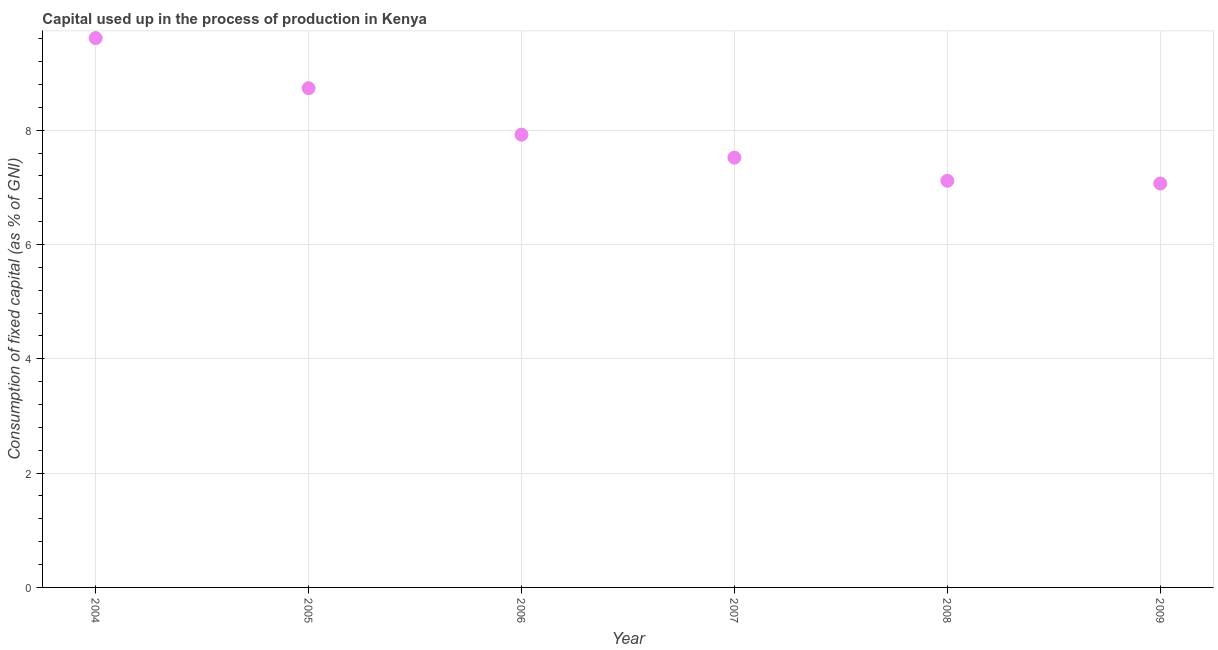What is the consumption of fixed capital in 2008?
Your response must be concise. 7.12. Across all years, what is the maximum consumption of fixed capital?
Keep it short and to the point. 9.61. Across all years, what is the minimum consumption of fixed capital?
Keep it short and to the point. 7.07. What is the sum of the consumption of fixed capital?
Provide a short and direct response. 47.97. What is the difference between the consumption of fixed capital in 2007 and 2008?
Offer a terse response. 0.4. What is the average consumption of fixed capital per year?
Provide a short and direct response. 8. What is the median consumption of fixed capital?
Your answer should be compact. 7.72. What is the ratio of the consumption of fixed capital in 2007 to that in 2008?
Provide a short and direct response. 1.06. Is the consumption of fixed capital in 2004 less than that in 2009?
Ensure brevity in your answer.  No. Is the difference between the consumption of fixed capital in 2004 and 2009 greater than the difference between any two years?
Offer a very short reply. Yes. What is the difference between the highest and the second highest consumption of fixed capital?
Give a very brief answer. 0.88. What is the difference between the highest and the lowest consumption of fixed capital?
Offer a terse response. 2.54. How many dotlines are there?
Your response must be concise. 1. How many years are there in the graph?
Offer a very short reply. 6. Are the values on the major ticks of Y-axis written in scientific E-notation?
Your response must be concise. No. What is the title of the graph?
Provide a succinct answer. Capital used up in the process of production in Kenya. What is the label or title of the X-axis?
Provide a short and direct response. Year. What is the label or title of the Y-axis?
Offer a terse response. Consumption of fixed capital (as % of GNI). What is the Consumption of fixed capital (as % of GNI) in 2004?
Your answer should be compact. 9.61. What is the Consumption of fixed capital (as % of GNI) in 2005?
Provide a succinct answer. 8.74. What is the Consumption of fixed capital (as % of GNI) in 2006?
Give a very brief answer. 7.92. What is the Consumption of fixed capital (as % of GNI) in 2007?
Offer a very short reply. 7.52. What is the Consumption of fixed capital (as % of GNI) in 2008?
Keep it short and to the point. 7.12. What is the Consumption of fixed capital (as % of GNI) in 2009?
Provide a short and direct response. 7.07. What is the difference between the Consumption of fixed capital (as % of GNI) in 2004 and 2005?
Your response must be concise. 0.88. What is the difference between the Consumption of fixed capital (as % of GNI) in 2004 and 2006?
Offer a very short reply. 1.69. What is the difference between the Consumption of fixed capital (as % of GNI) in 2004 and 2007?
Give a very brief answer. 2.09. What is the difference between the Consumption of fixed capital (as % of GNI) in 2004 and 2008?
Provide a succinct answer. 2.5. What is the difference between the Consumption of fixed capital (as % of GNI) in 2004 and 2009?
Provide a succinct answer. 2.54. What is the difference between the Consumption of fixed capital (as % of GNI) in 2005 and 2006?
Your response must be concise. 0.81. What is the difference between the Consumption of fixed capital (as % of GNI) in 2005 and 2007?
Provide a succinct answer. 1.22. What is the difference between the Consumption of fixed capital (as % of GNI) in 2005 and 2008?
Provide a short and direct response. 1.62. What is the difference between the Consumption of fixed capital (as % of GNI) in 2005 and 2009?
Provide a succinct answer. 1.67. What is the difference between the Consumption of fixed capital (as % of GNI) in 2006 and 2007?
Your response must be concise. 0.4. What is the difference between the Consumption of fixed capital (as % of GNI) in 2006 and 2008?
Keep it short and to the point. 0.81. What is the difference between the Consumption of fixed capital (as % of GNI) in 2006 and 2009?
Provide a succinct answer. 0.86. What is the difference between the Consumption of fixed capital (as % of GNI) in 2007 and 2008?
Your answer should be compact. 0.4. What is the difference between the Consumption of fixed capital (as % of GNI) in 2007 and 2009?
Your answer should be compact. 0.45. What is the difference between the Consumption of fixed capital (as % of GNI) in 2008 and 2009?
Keep it short and to the point. 0.05. What is the ratio of the Consumption of fixed capital (as % of GNI) in 2004 to that in 2005?
Your answer should be very brief. 1.1. What is the ratio of the Consumption of fixed capital (as % of GNI) in 2004 to that in 2006?
Keep it short and to the point. 1.21. What is the ratio of the Consumption of fixed capital (as % of GNI) in 2004 to that in 2007?
Offer a very short reply. 1.28. What is the ratio of the Consumption of fixed capital (as % of GNI) in 2004 to that in 2008?
Keep it short and to the point. 1.35. What is the ratio of the Consumption of fixed capital (as % of GNI) in 2004 to that in 2009?
Your answer should be very brief. 1.36. What is the ratio of the Consumption of fixed capital (as % of GNI) in 2005 to that in 2006?
Give a very brief answer. 1.1. What is the ratio of the Consumption of fixed capital (as % of GNI) in 2005 to that in 2007?
Keep it short and to the point. 1.16. What is the ratio of the Consumption of fixed capital (as % of GNI) in 2005 to that in 2008?
Your answer should be very brief. 1.23. What is the ratio of the Consumption of fixed capital (as % of GNI) in 2005 to that in 2009?
Keep it short and to the point. 1.24. What is the ratio of the Consumption of fixed capital (as % of GNI) in 2006 to that in 2007?
Offer a very short reply. 1.05. What is the ratio of the Consumption of fixed capital (as % of GNI) in 2006 to that in 2008?
Your answer should be compact. 1.11. What is the ratio of the Consumption of fixed capital (as % of GNI) in 2006 to that in 2009?
Your response must be concise. 1.12. What is the ratio of the Consumption of fixed capital (as % of GNI) in 2007 to that in 2008?
Keep it short and to the point. 1.06. What is the ratio of the Consumption of fixed capital (as % of GNI) in 2007 to that in 2009?
Your response must be concise. 1.06. 